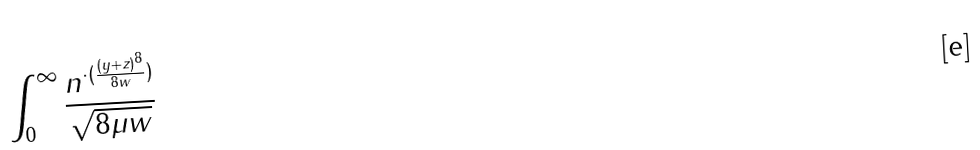<formula> <loc_0><loc_0><loc_500><loc_500>\int _ { 0 } ^ { \infty } \frac { n ^ { \cdot ( \frac { ( y + z ) ^ { 8 } } { 8 w } ) } } { \sqrt { 8 \mu w } }</formula> 